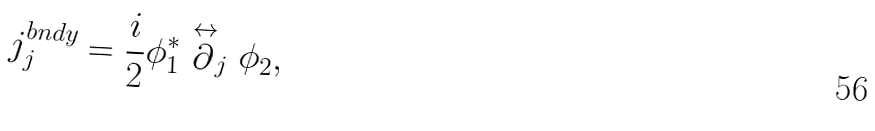<formula> <loc_0><loc_0><loc_500><loc_500>j ^ { b n d y } _ { j } = \frac { i } { 2 } \phi _ { 1 } ^ { * } \stackrel { \leftrightarrow } \partial _ { j } \phi _ { 2 } ,</formula> 